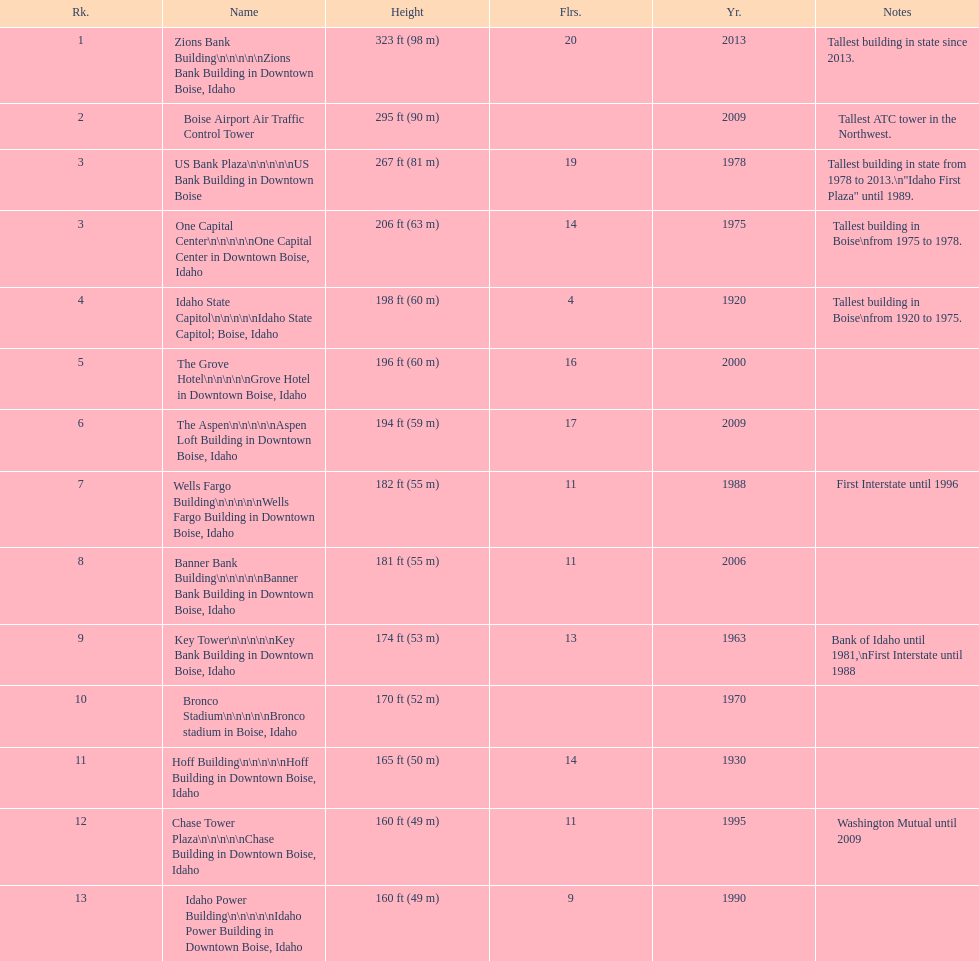How tall (in meters) is the tallest building? 98 m. 